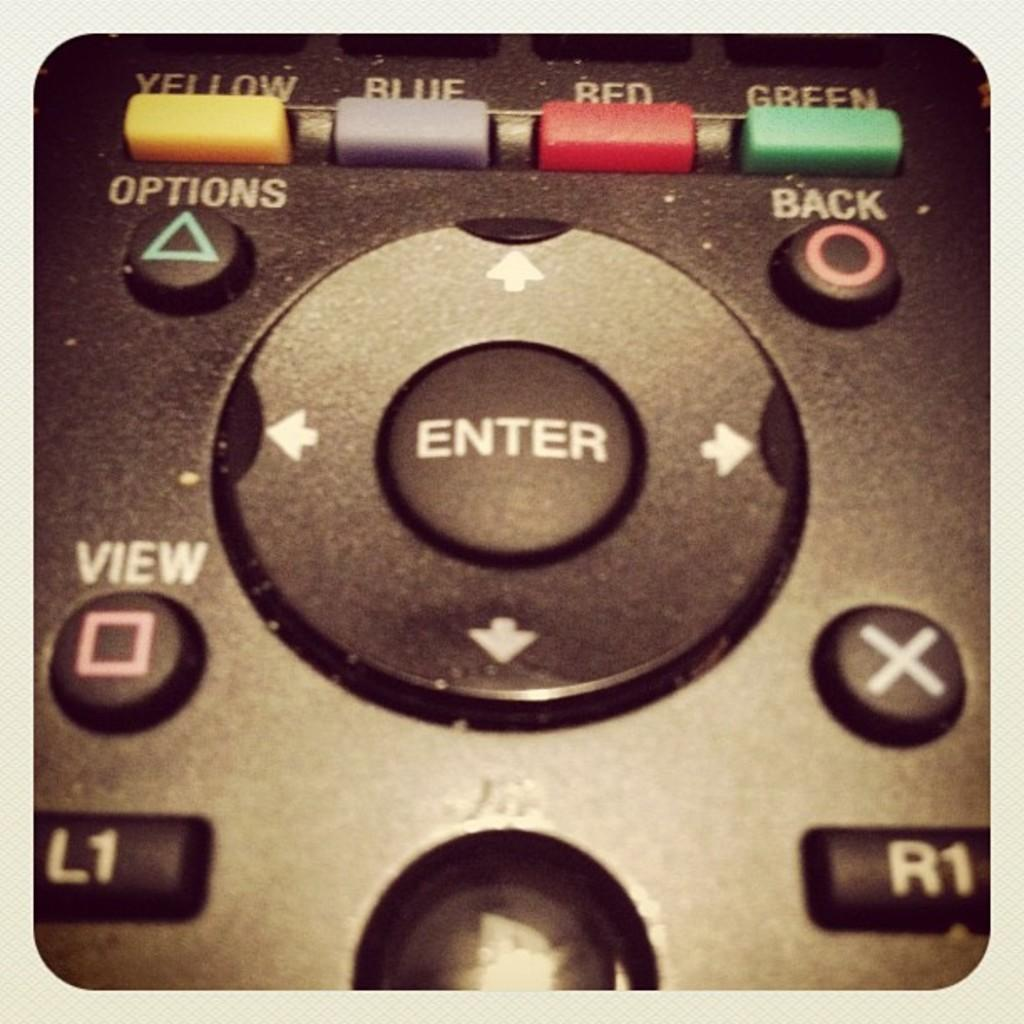<image>
Present a compact description of the photo's key features. A close up of a remote control and the enter button. 